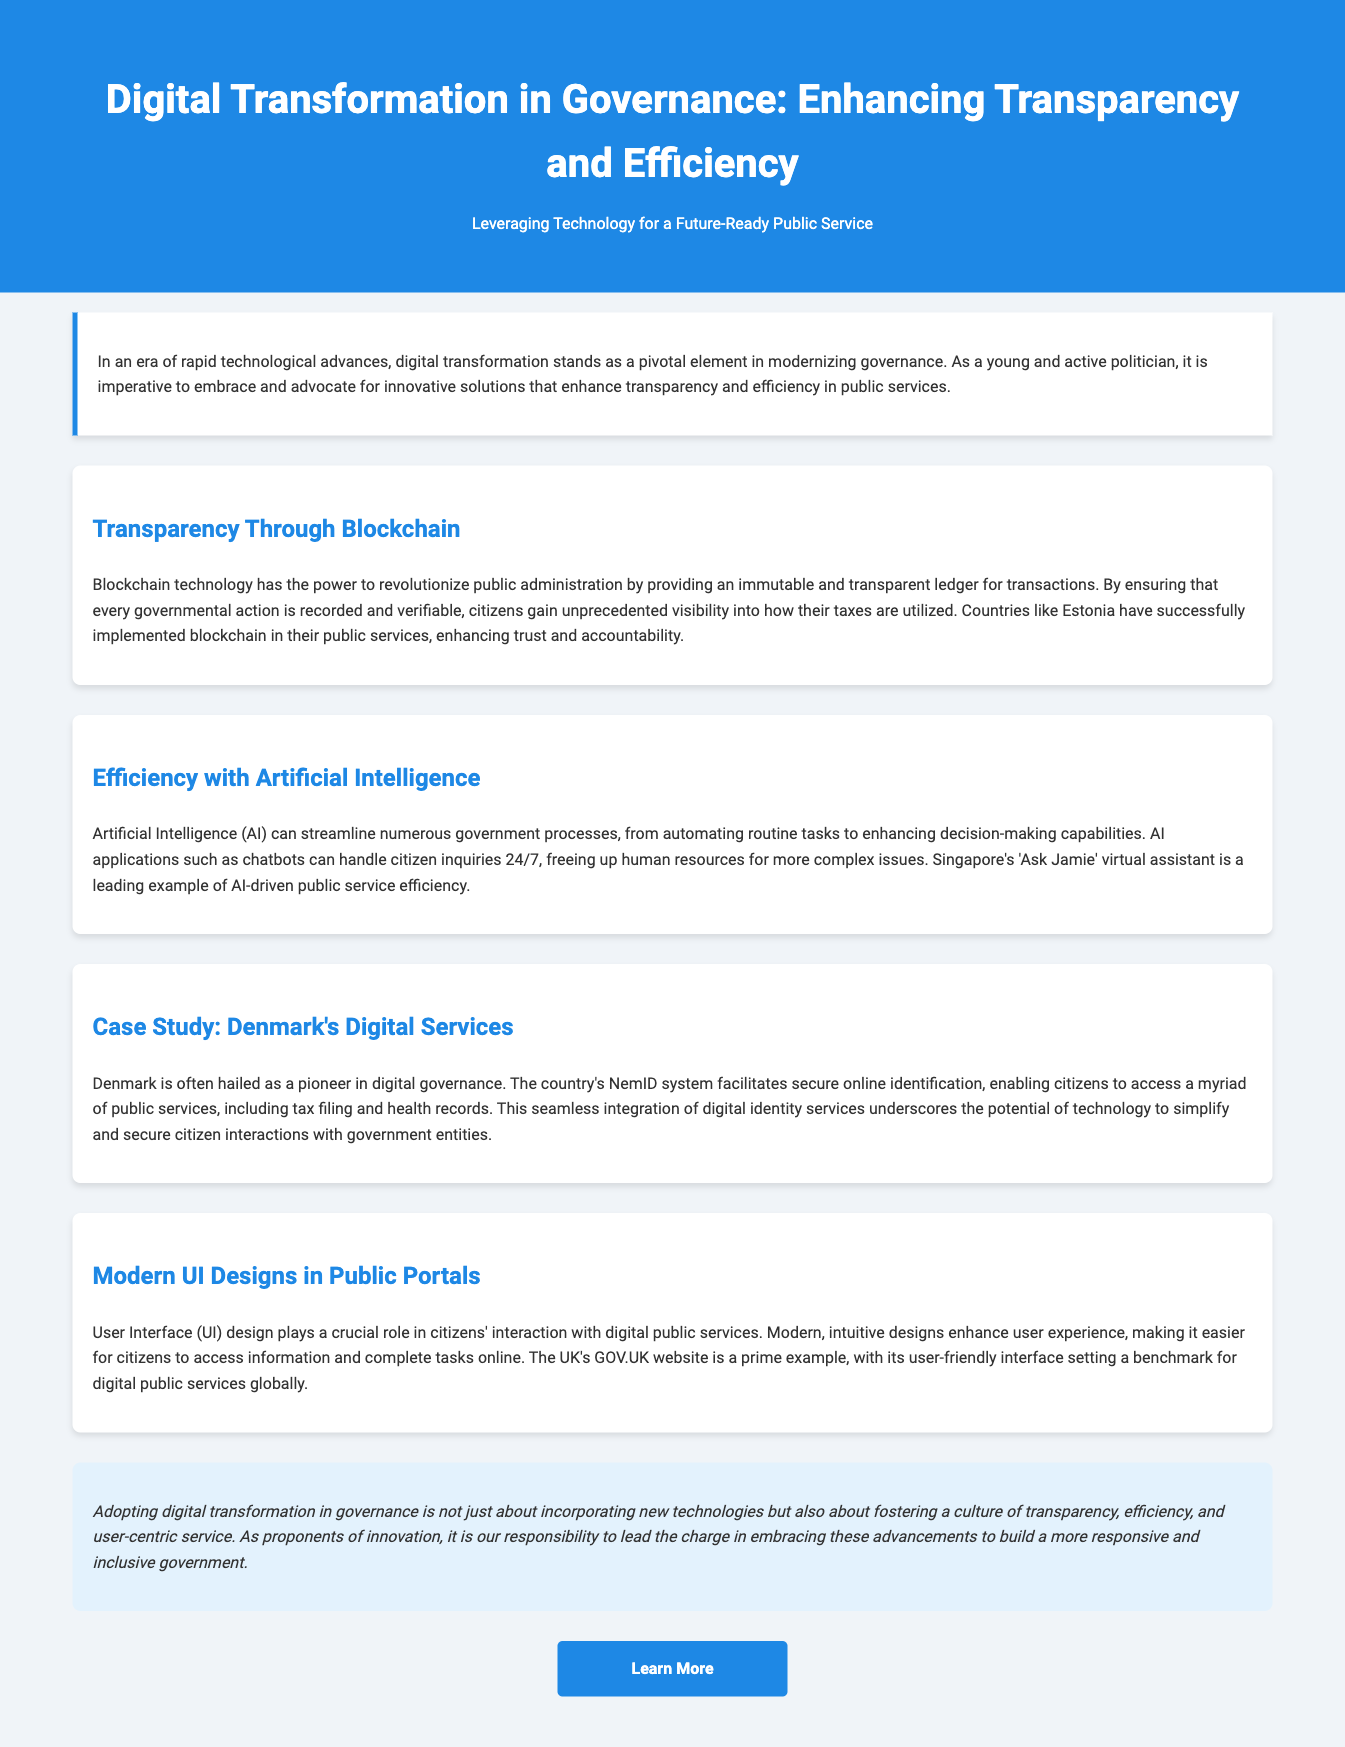What is the title of the advertisement? The title of the advertisement is prominently displayed in the header section of the document.
Answer: Digital Transformation in Governance: Enhancing Transparency and Efficiency How does blockchain enhance transparency? The document mentions that blockchain provides an immutable and transparent ledger for transactions in public administration.
Answer: Immutable and transparent ledger What AI application is mentioned for handling citizen inquiries? The document states an example of AI application that facilitates 24/7 citizen inquiries.
Answer: Chatbots Which country is cited as a pioneer in digital governance? The section detailing a successful implementation references a specific country known for its digital governance efforts.
Answer: Denmark What system does Denmark use for secure online identification? The advertisement provides the name of the system that facilitates secure online identification for Danish citizens.
Answer: NemID What key feature does the UK's GOV.UK website exemplify? The document highlights a specific attribute of the UK's GOV.UK website in relation to user experience in digital public services.
Answer: User-friendly interface What does digital transformation in governance aim to foster? The conclusion summarizes the overall goal of digital transformation in public governance as stated in the document.
Answer: Transparency, efficiency, and user-centric service Which technology is discussed as streamlining government processes? The advertisement specifies a particular technology that automates tasks and enhances decision-making in governance.
Answer: Artificial Intelligence 